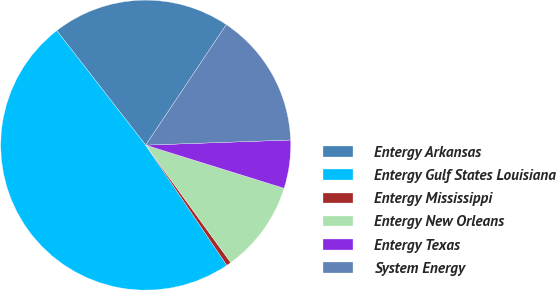Convert chart to OTSL. <chart><loc_0><loc_0><loc_500><loc_500><pie_chart><fcel>Entergy Arkansas<fcel>Entergy Gulf States Louisiana<fcel>Entergy Mississippi<fcel>Entergy New Orleans<fcel>Entergy Texas<fcel>System Energy<nl><fcel>19.89%<fcel>48.93%<fcel>0.53%<fcel>10.21%<fcel>5.37%<fcel>15.05%<nl></chart> 